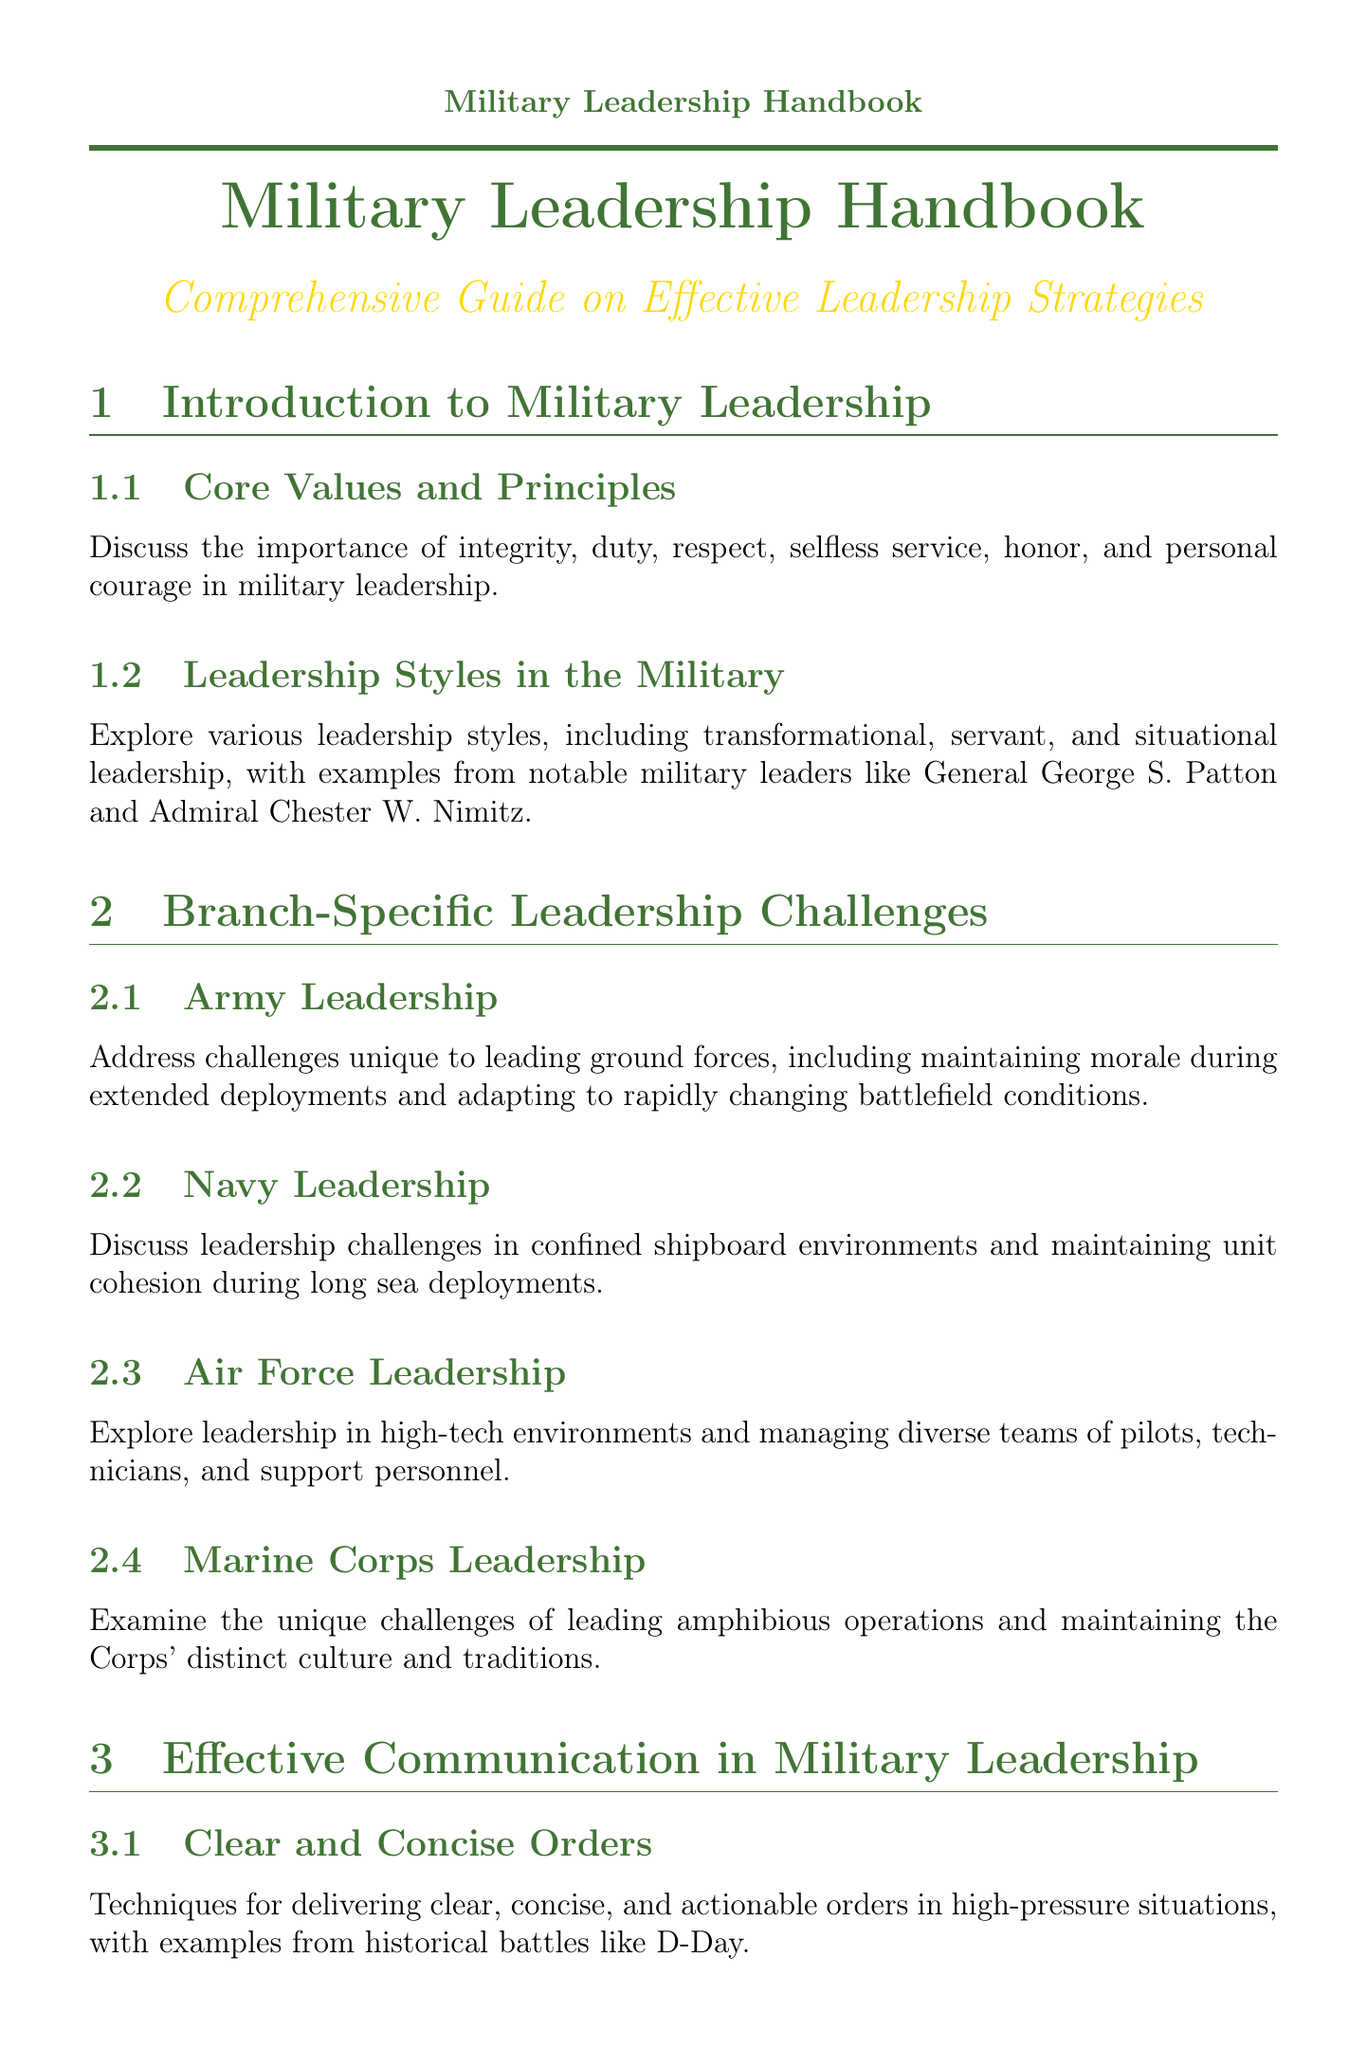what are the core values in military leadership? The core values discussed in the document include integrity, duty, respect, selfless service, honor, and personal courage.
Answer: integrity, duty, respect, selfless service, honor, personal courage who are two notable military leaders mentioned in the leadership styles section? The leadership styles section explores examples from notable military leaders like General George S. Patton and Admiral Chester W. Nimitz.
Answer: General George S. Patton, Admiral Chester W. Nimitz what is a specific challenge faced by Navy leadership? The document states a challenge in Navy leadership is maintaining unit cohesion during long sea deployments.
Answer: maintaining unit cohesion during long sea deployments what is one technique for clear communication in military leadership? The document highlights techniques for delivering clear, concise, and actionable orders in high-pressure situations.
Answer: delivering clear, concise, and actionable orders name a case study mentioned in tactical decision-making. The tactical decision-making section includes case studies from the Battle of Fallujah and Operation Desert Storm.
Answer: Battle of Fallujah which branch of the military is associated with high-tech environments? The Air Force is associated with leadership in high-tech environments.
Answer: Air Force what type of exercises are suggested for team-building? The document discusses practical exercises and activities to foster trust and cooperation within military units.
Answer: practical exercises and activities what is one approach to developing future leaders? The document mentions strategies for identifying and nurturing leadership potential in subordinates.
Answer: identifying and nurturing leadership potential what major humanitarian event is referenced in the context of disaster relief? The document refers to the U.S. military's response to the 2010 Haiti earthquake as a significant humanitarian event.
Answer: 2010 Haiti earthquake 